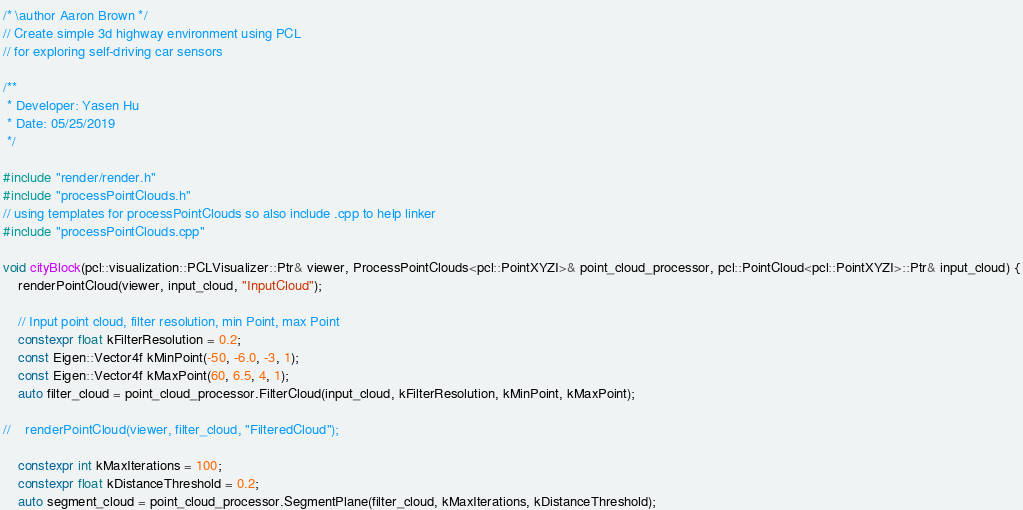<code> <loc_0><loc_0><loc_500><loc_500><_C++_>/* \author Aaron Brown */
// Create simple 3d highway environment using PCL
// for exploring self-driving car sensors

/**
 * Developer: Yasen Hu
 * Date: 05/25/2019
 */

#include "render/render.h"
#include "processPointClouds.h"
// using templates for processPointClouds so also include .cpp to help linker
#include "processPointClouds.cpp"

void cityBlock(pcl::visualization::PCLVisualizer::Ptr& viewer, ProcessPointClouds<pcl::PointXYZI>& point_cloud_processor, pcl::PointCloud<pcl::PointXYZI>::Ptr& input_cloud) {
    renderPointCloud(viewer, input_cloud, "InputCloud");

    // Input point cloud, filter resolution, min Point, max Point
    constexpr float kFilterResolution = 0.2;
    const Eigen::Vector4f kMinPoint(-50, -6.0, -3, 1);
    const Eigen::Vector4f kMaxPoint(60, 6.5, 4, 1);
    auto filter_cloud = point_cloud_processor.FilterCloud(input_cloud, kFilterResolution, kMinPoint, kMaxPoint);

//    renderPointCloud(viewer, filter_cloud, "FilteredCloud");

    constexpr int kMaxIterations = 100;
    constexpr float kDistanceThreshold = 0.2;
    auto segment_cloud = point_cloud_processor.SegmentPlane(filter_cloud, kMaxIterations, kDistanceThreshold);
</code> 